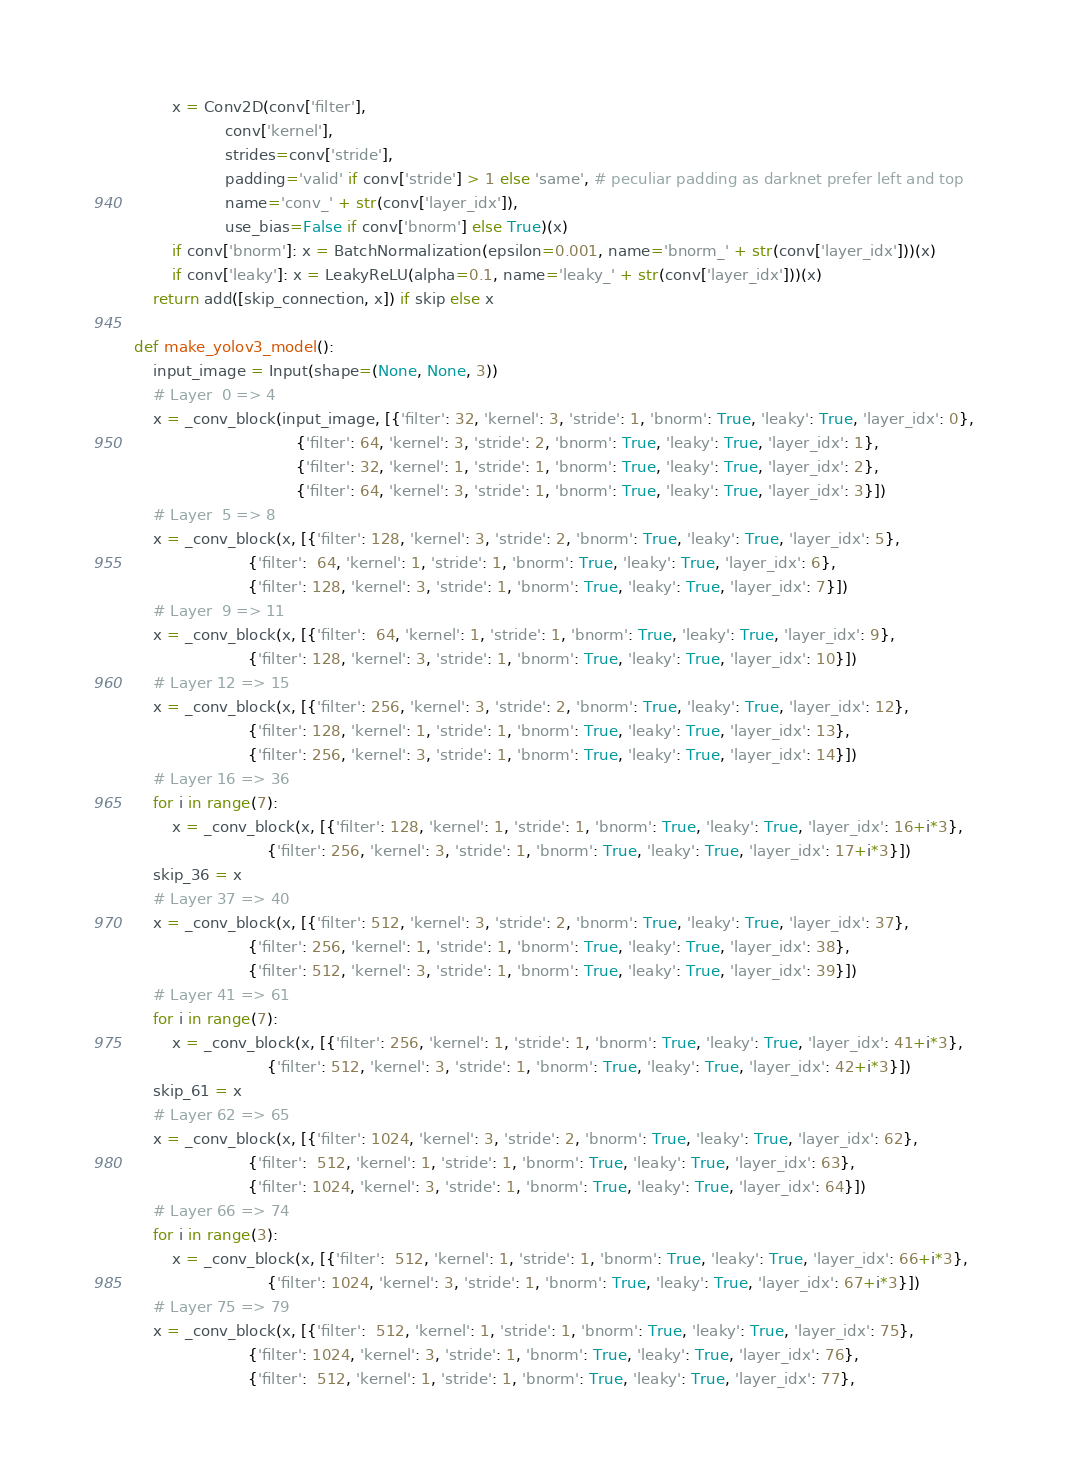Convert code to text. <code><loc_0><loc_0><loc_500><loc_500><_Python_>		x = Conv2D(conv['filter'],
				   conv['kernel'],
				   strides=conv['stride'],
				   padding='valid' if conv['stride'] > 1 else 'same', # peculiar padding as darknet prefer left and top
				   name='conv_' + str(conv['layer_idx']),
				   use_bias=False if conv['bnorm'] else True)(x)
		if conv['bnorm']: x = BatchNormalization(epsilon=0.001, name='bnorm_' + str(conv['layer_idx']))(x)
		if conv['leaky']: x = LeakyReLU(alpha=0.1, name='leaky_' + str(conv['layer_idx']))(x)
	return add([skip_connection, x]) if skip else x
 
def make_yolov3_model():
	input_image = Input(shape=(None, None, 3))
	# Layer  0 => 4
	x = _conv_block(input_image, [{'filter': 32, 'kernel': 3, 'stride': 1, 'bnorm': True, 'leaky': True, 'layer_idx': 0},
								  {'filter': 64, 'kernel': 3, 'stride': 2, 'bnorm': True, 'leaky': True, 'layer_idx': 1},
								  {'filter': 32, 'kernel': 1, 'stride': 1, 'bnorm': True, 'leaky': True, 'layer_idx': 2},
								  {'filter': 64, 'kernel': 3, 'stride': 1, 'bnorm': True, 'leaky': True, 'layer_idx': 3}])
	# Layer  5 => 8
	x = _conv_block(x, [{'filter': 128, 'kernel': 3, 'stride': 2, 'bnorm': True, 'leaky': True, 'layer_idx': 5},
						{'filter':  64, 'kernel': 1, 'stride': 1, 'bnorm': True, 'leaky': True, 'layer_idx': 6},
						{'filter': 128, 'kernel': 3, 'stride': 1, 'bnorm': True, 'leaky': True, 'layer_idx': 7}])
	# Layer  9 => 11
	x = _conv_block(x, [{'filter':  64, 'kernel': 1, 'stride': 1, 'bnorm': True, 'leaky': True, 'layer_idx': 9},
						{'filter': 128, 'kernel': 3, 'stride': 1, 'bnorm': True, 'leaky': True, 'layer_idx': 10}])
	# Layer 12 => 15
	x = _conv_block(x, [{'filter': 256, 'kernel': 3, 'stride': 2, 'bnorm': True, 'leaky': True, 'layer_idx': 12},
						{'filter': 128, 'kernel': 1, 'stride': 1, 'bnorm': True, 'leaky': True, 'layer_idx': 13},
						{'filter': 256, 'kernel': 3, 'stride': 1, 'bnorm': True, 'leaky': True, 'layer_idx': 14}])
	# Layer 16 => 36
	for i in range(7):
		x = _conv_block(x, [{'filter': 128, 'kernel': 1, 'stride': 1, 'bnorm': True, 'leaky': True, 'layer_idx': 16+i*3},
							{'filter': 256, 'kernel': 3, 'stride': 1, 'bnorm': True, 'leaky': True, 'layer_idx': 17+i*3}])
	skip_36 = x
	# Layer 37 => 40
	x = _conv_block(x, [{'filter': 512, 'kernel': 3, 'stride': 2, 'bnorm': True, 'leaky': True, 'layer_idx': 37},
						{'filter': 256, 'kernel': 1, 'stride': 1, 'bnorm': True, 'leaky': True, 'layer_idx': 38},
						{'filter': 512, 'kernel': 3, 'stride': 1, 'bnorm': True, 'leaky': True, 'layer_idx': 39}])
	# Layer 41 => 61
	for i in range(7):
		x = _conv_block(x, [{'filter': 256, 'kernel': 1, 'stride': 1, 'bnorm': True, 'leaky': True, 'layer_idx': 41+i*3},
							{'filter': 512, 'kernel': 3, 'stride': 1, 'bnorm': True, 'leaky': True, 'layer_idx': 42+i*3}])
	skip_61 = x
	# Layer 62 => 65
	x = _conv_block(x, [{'filter': 1024, 'kernel': 3, 'stride': 2, 'bnorm': True, 'leaky': True, 'layer_idx': 62},
						{'filter':  512, 'kernel': 1, 'stride': 1, 'bnorm': True, 'leaky': True, 'layer_idx': 63},
						{'filter': 1024, 'kernel': 3, 'stride': 1, 'bnorm': True, 'leaky': True, 'layer_idx': 64}])
	# Layer 66 => 74
	for i in range(3):
		x = _conv_block(x, [{'filter':  512, 'kernel': 1, 'stride': 1, 'bnorm': True, 'leaky': True, 'layer_idx': 66+i*3},
							{'filter': 1024, 'kernel': 3, 'stride': 1, 'bnorm': True, 'leaky': True, 'layer_idx': 67+i*3}])
	# Layer 75 => 79
	x = _conv_block(x, [{'filter':  512, 'kernel': 1, 'stride': 1, 'bnorm': True, 'leaky': True, 'layer_idx': 75},
						{'filter': 1024, 'kernel': 3, 'stride': 1, 'bnorm': True, 'leaky': True, 'layer_idx': 76},
						{'filter':  512, 'kernel': 1, 'stride': 1, 'bnorm': True, 'leaky': True, 'layer_idx': 77},</code> 